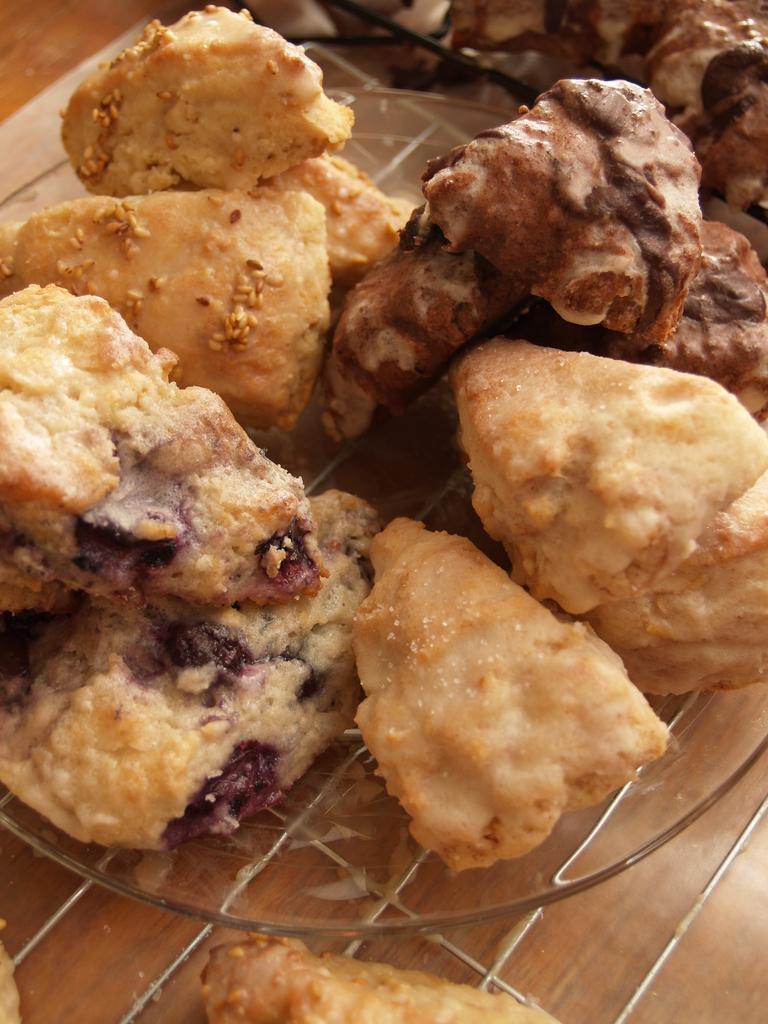How would you summarize this image in a sentence or two? In this image I can see a table , on the table I can see plate , on the plate I can see bread pieces. 